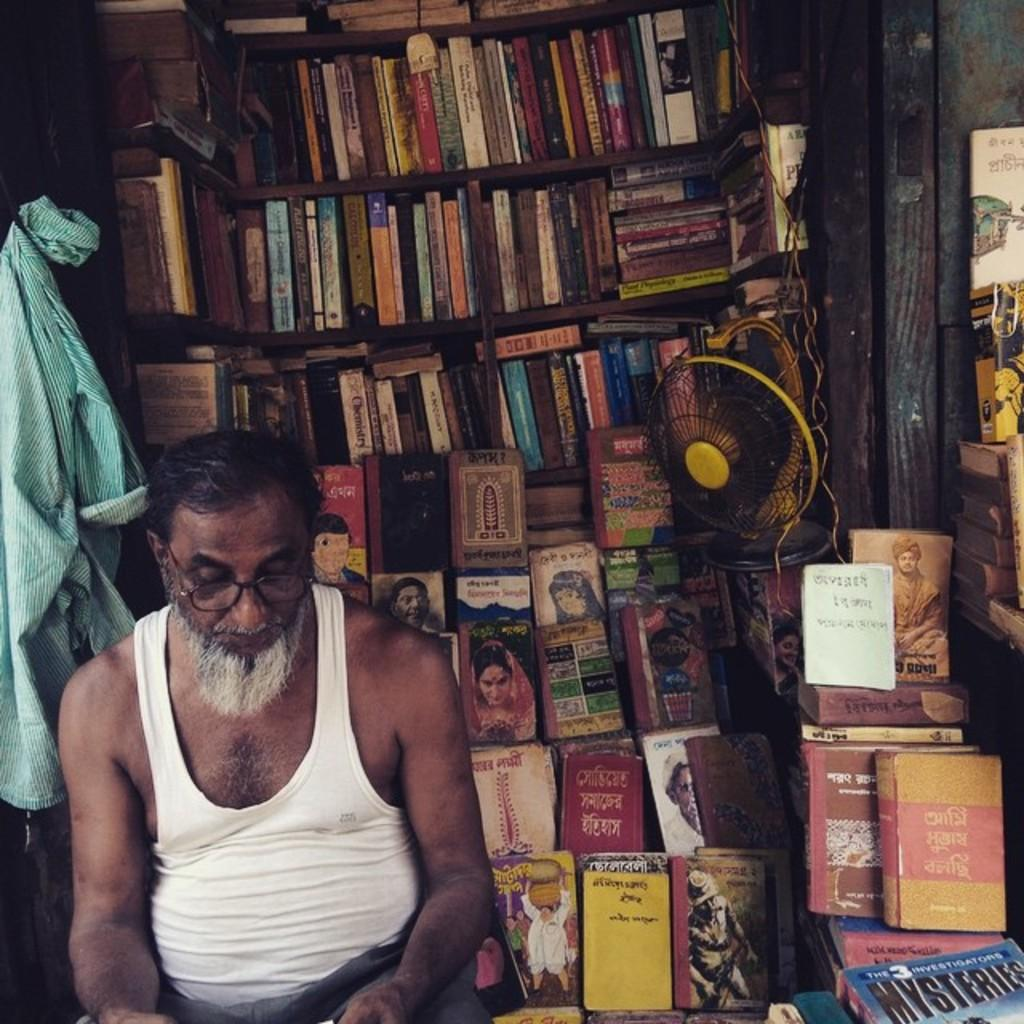What is the man in the image doing? The man is sitting in the image. What can be seen on the racks in the image? There are books kept in racks. Where is the shirt located in the image? The shirt is hung on a hook in the image. What is attached to the rack in the image? There is a table fan attached to a rack in the image. Can you see any attractions or a lake in the image? There are no attractions or a lake present in the image. Is there any milk visible in the image? There is no milk present in the image. 